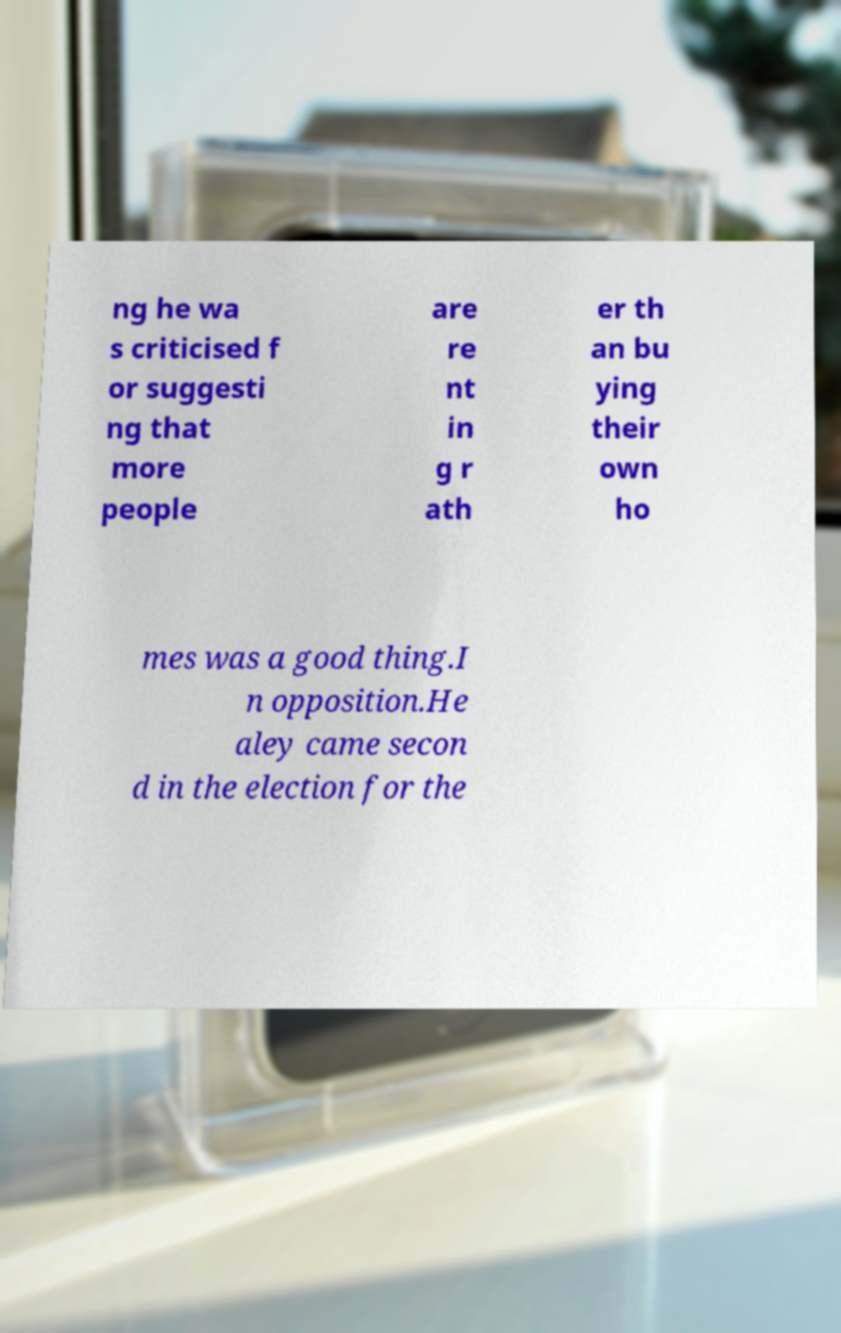What messages or text are displayed in this image? I need them in a readable, typed format. ng he wa s criticised f or suggesti ng that more people are re nt in g r ath er th an bu ying their own ho mes was a good thing.I n opposition.He aley came secon d in the election for the 